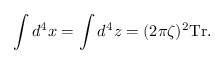Convert formula to latex. <formula><loc_0><loc_0><loc_500><loc_500>\int d ^ { 4 } x = \int d ^ { 4 } z = ( 2 \pi \zeta ) ^ { 2 } T r .</formula> 